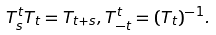Convert formula to latex. <formula><loc_0><loc_0><loc_500><loc_500>T ^ { t } _ { s } T _ { t } = T _ { t + s } , T ^ { t } _ { - t } = ( T _ { t } ) ^ { - 1 } .</formula> 